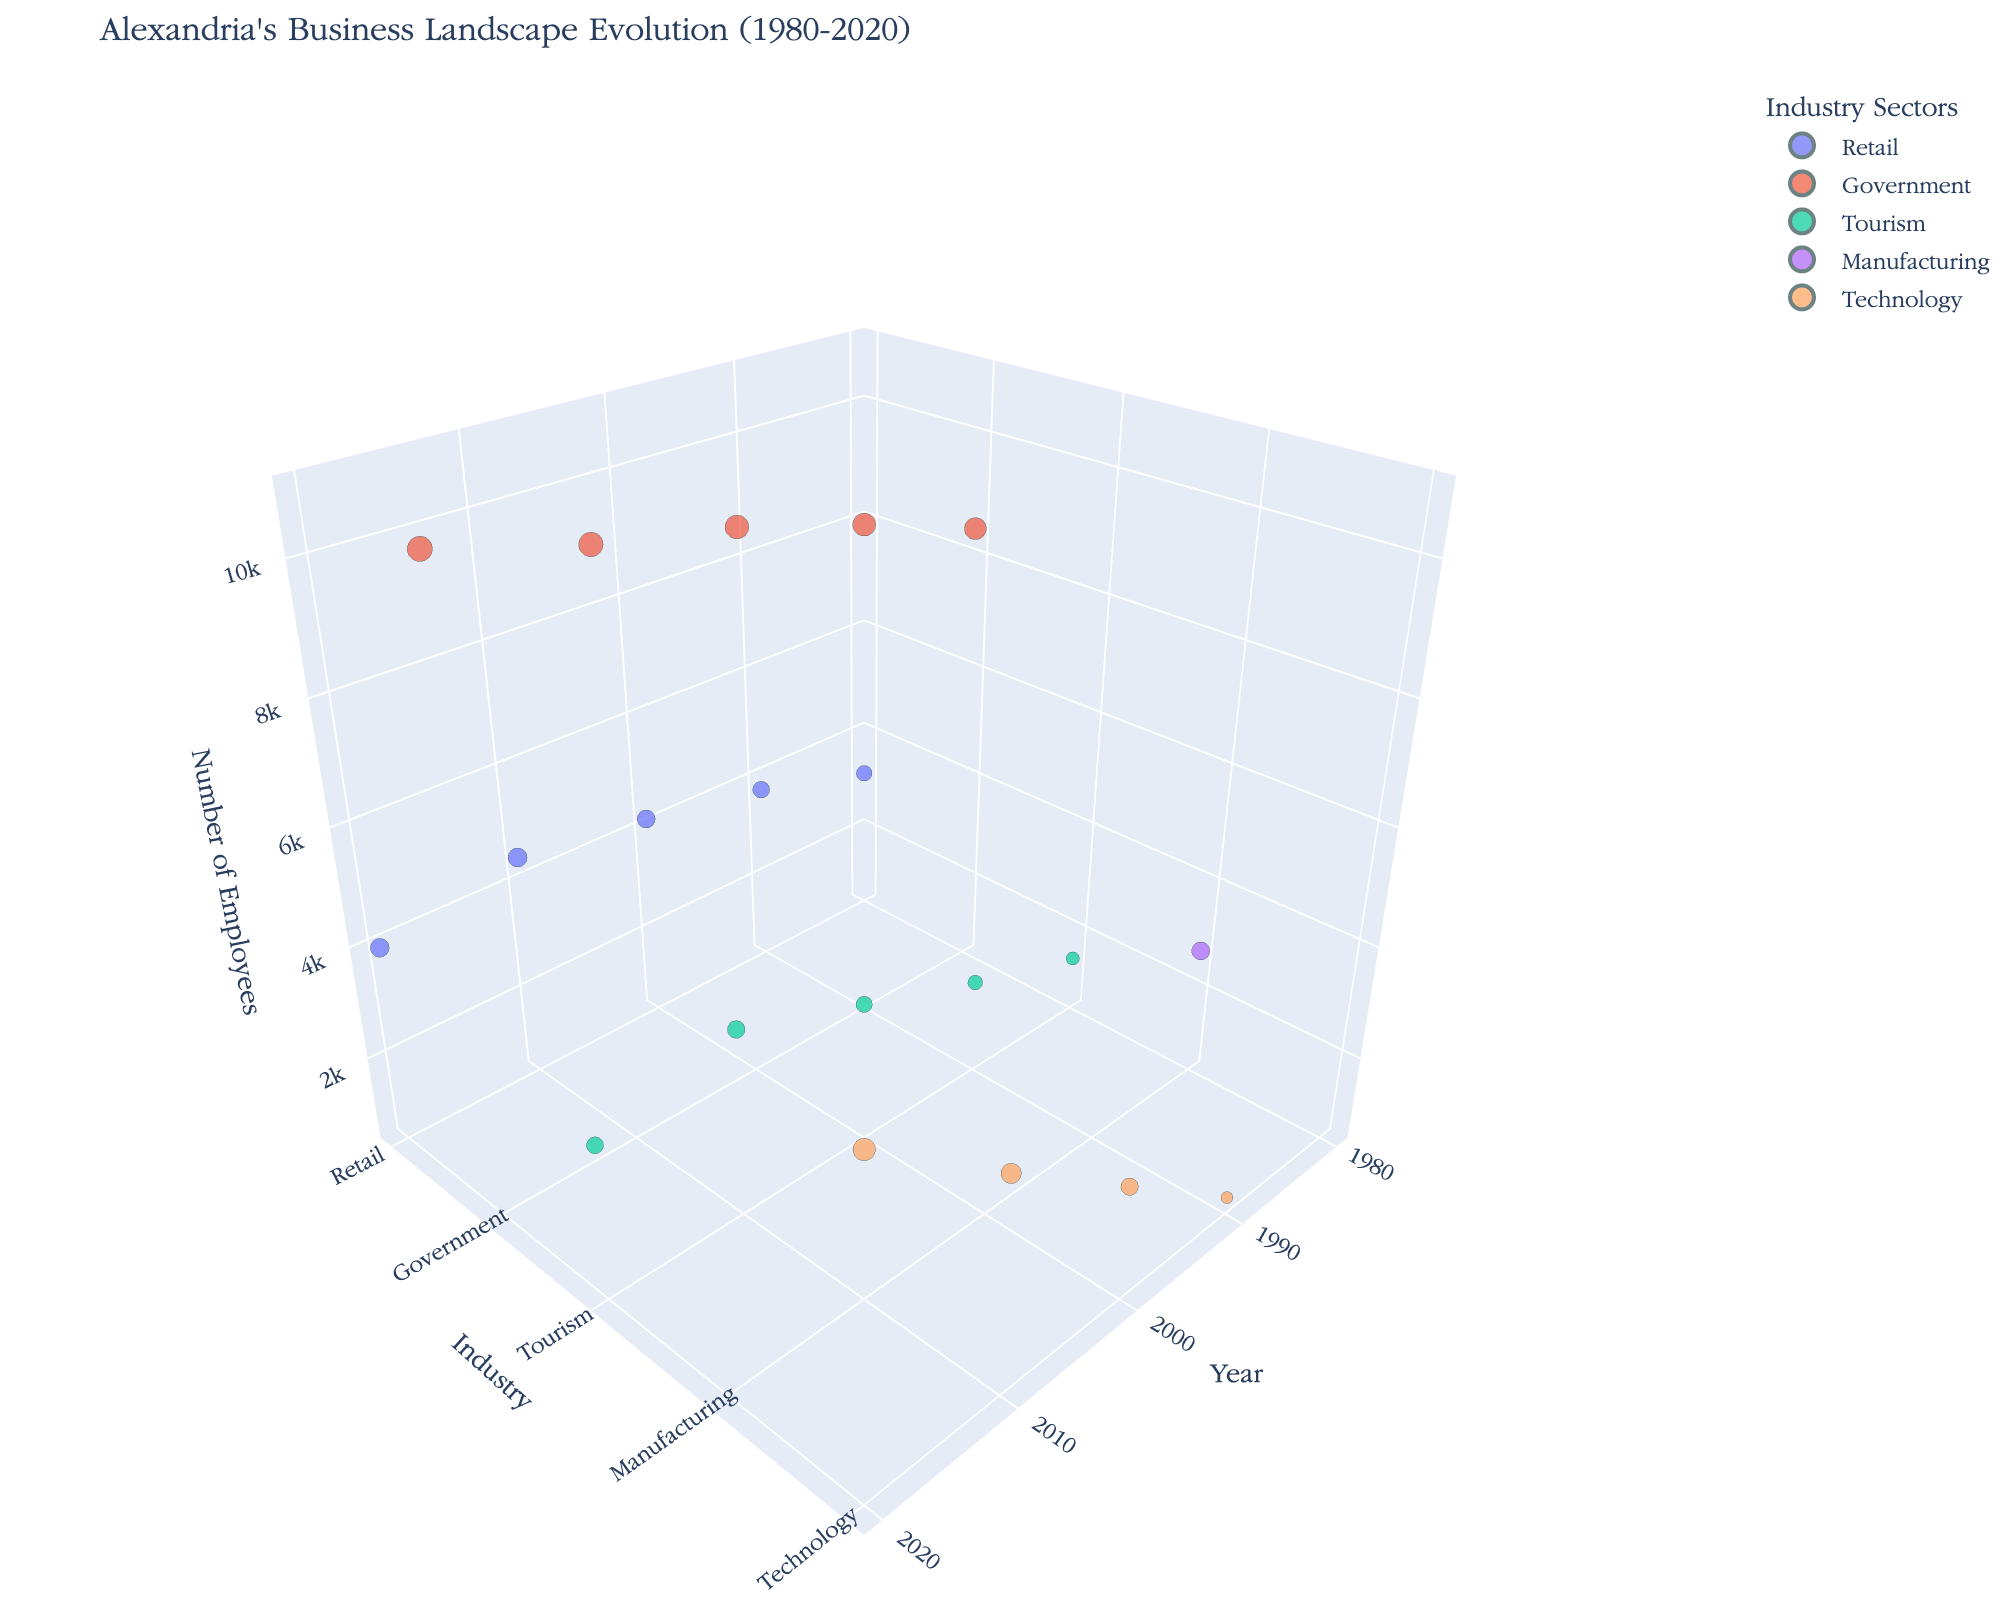What's the title of the figure? The title is displayed at the top of the figure. It is "Alexandria's Business Landscape Evolution (1980-2020)."
Answer: Alexandria's Business Landscape Evolution (1980-2020) Which industry had the highest number of employees in 1980? By looking at the 1980 data within the 3D bubble chart and checking the z-axis (employees), the Government sector had the highest number of employees.
Answer: Government How many establishments were there in the retail sector in 2020? Referring to the year 2020 and the Retail sector, the bubble's hover data indicates the number of establishments.
Answer: 580 Which industry has grown the most in terms of the number of employees from 1980 to 2020? By comparing the number of employees in 1980 and 2020 for each industry, the Technology sector shows the most growth, from 0 employees listed in 1980 to 6000 in 2020.
Answer: Technology What's the difference in revenue between the Government and Retail sectors in 2010? From the 2010 data, the Government sector had a revenue of 1100 million and the Retail sector had 400 million. The difference is 1100 - 400 million.
Answer: 700 million Which industry had the smallest increase in the number of employees between 1980 and 2020? Looking at the data for 1980 and 2020, the Retail sector increased from 3200 to 4000 employees, showing the smallest increase compared to other industries.
Answer: Retail What are the x, y, and z-axis labels? The x-axis represents the year, the y-axis represents the industry, and the z-axis represents the number of employees. These labels are observed on the axes themselves.
Answer: Year, Industry, Number of Employees Compare the size of the bubbles for the Technology sector in 1990 and 2020. Which one is bigger? The Technology sector bubble in 2020 is larger, indicating a higher revenue as the bubble size is proportional to the revenue. The revenue grew from 60 million in 1990 to 780 million in 2020.
Answer: 2020 How many industries were represented in the year 2000? Observing the year 2000 on the x-axis and checking the corresponding points, there are four industries: Retail, Government, Tourism, and Technology.
Answer: 4 What does a larger bubble represent in this chart? In the 3D bubble chart, a larger bubble represents higher revenue, as the bubble size is adjusted based on the revenue in millions.
Answer: Higher revenue 